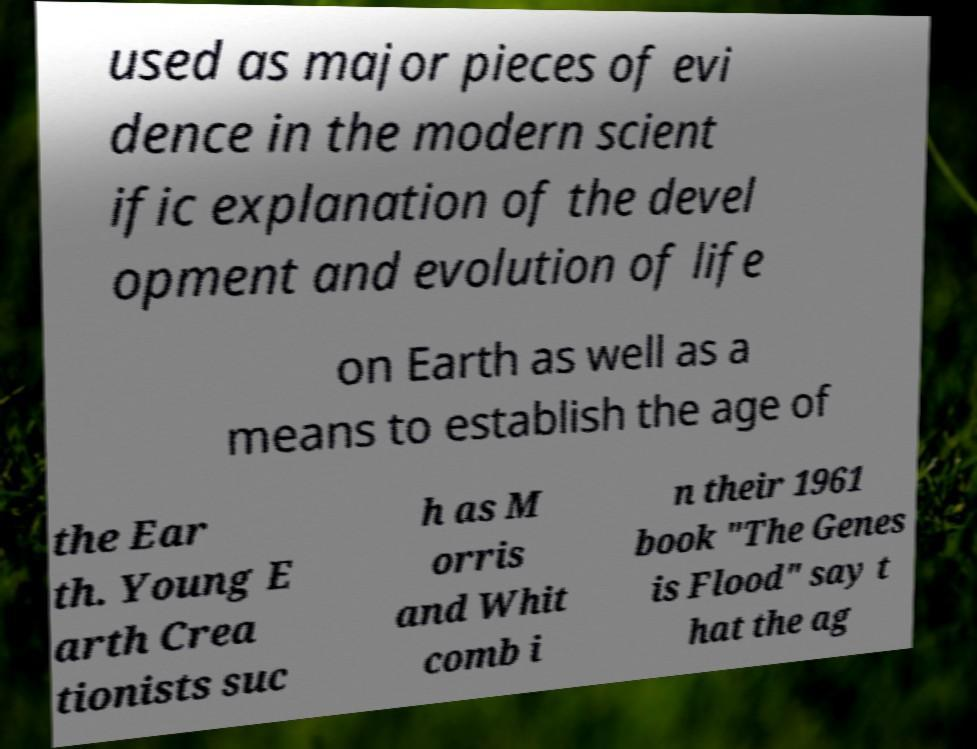Could you assist in decoding the text presented in this image and type it out clearly? used as major pieces of evi dence in the modern scient ific explanation of the devel opment and evolution of life on Earth as well as a means to establish the age of the Ear th. Young E arth Crea tionists suc h as M orris and Whit comb i n their 1961 book "The Genes is Flood" say t hat the ag 